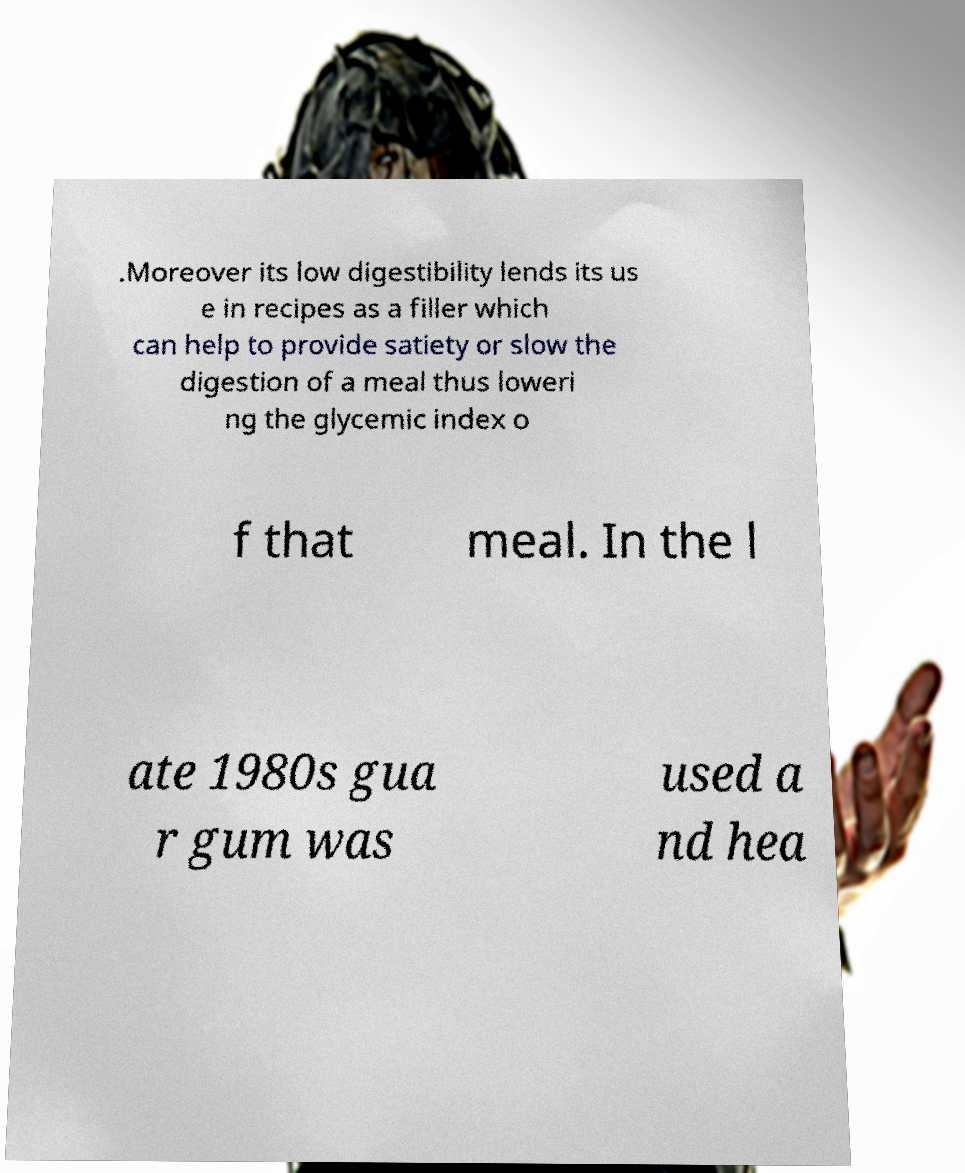Can you accurately transcribe the text from the provided image for me? .Moreover its low digestibility lends its us e in recipes as a filler which can help to provide satiety or slow the digestion of a meal thus loweri ng the glycemic index o f that meal. In the l ate 1980s gua r gum was used a nd hea 